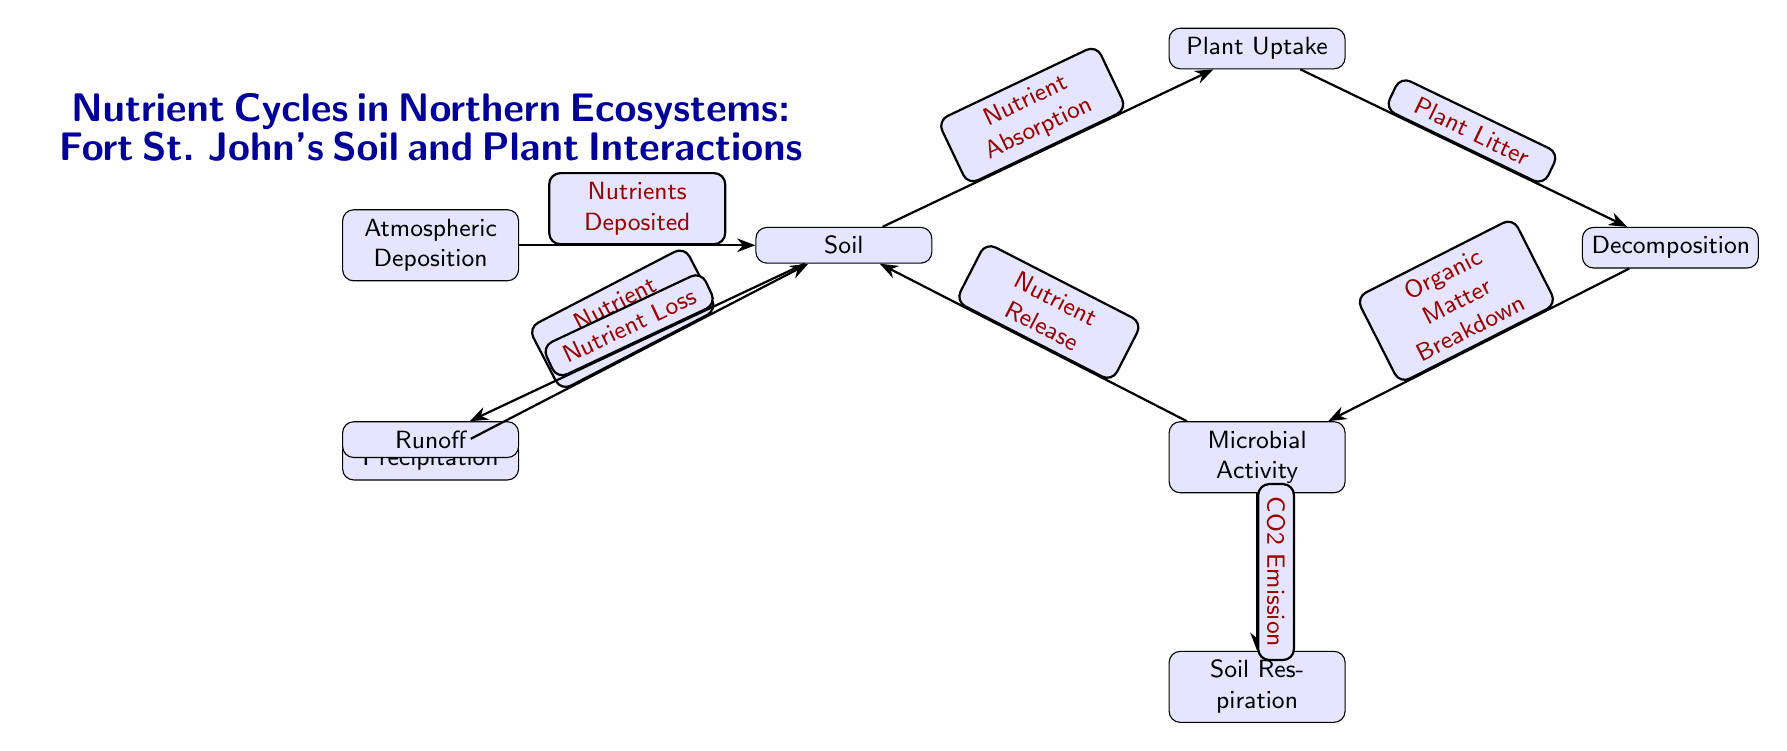What is the main title of the diagram? The title is explicitly stated above the diagram components, and it indicates the focus on nutrient cycles and interactions in Fort St. John's ecosystems.
Answer: Nutrient Cycles in Northern Ecosystems: Fort St. John's Soil and Plant Interactions How many nodes are illustrated in the diagram? By counting all distinct entities presented in the diagram, we identify that there are a total of seven nodes including Atmospheric Deposition, Precipitation, Soil, Plant Uptake, Decomposition, Microbial Activity, and Soil Respiration.
Answer: 7 What relationship connects Atmospheric Deposition to Soil? The connection labeled "Nutrients Deposited" directly indicates how atmospheric deposition influences soil by supplying nutrients.
Answer: Nutrients Deposited Which node represents the process that occurs after Plant Uptake? Following Plant Uptake, the process represented is Decomposition, as indicated by the directional flow from Plant Uptake to Decomposition in the diagram.
Answer: Decomposition What is released back into the soil after Microbial Activity? The flow from Microbial Activity back to Soil is described as "Nutrient Release," meaning that this process contributes nutrients back into the soil.
Answer: Nutrient Release What does Soil Respiration release into the atmosphere? The diagram specifies that Soil Respiration is associated with "CO2 Emission," indicating that this process contributes carbon dioxide back into the atmosphere.
Answer: CO2 Emission Which process causes Nutrient Loss from the Soil? The diagram states that runoff is associated with "Nutrient Loss," illustrating how nutrients are lost from the soil through runoff.
Answer: Nutrient Loss What indicates the relationship between Soil and Plant Uptake? The connection is defined as "Nutrient Absorption," indicating how soil provides nutrients that are absorbed by plants.
Answer: Nutrient Absorption Which process directly follows Decomposition? The next step after Decomposition is Microbial Activity, as shown by the directional arrow flowing from Decomposition to Microbial Activity in the diagram.
Answer: Microbial Activity 